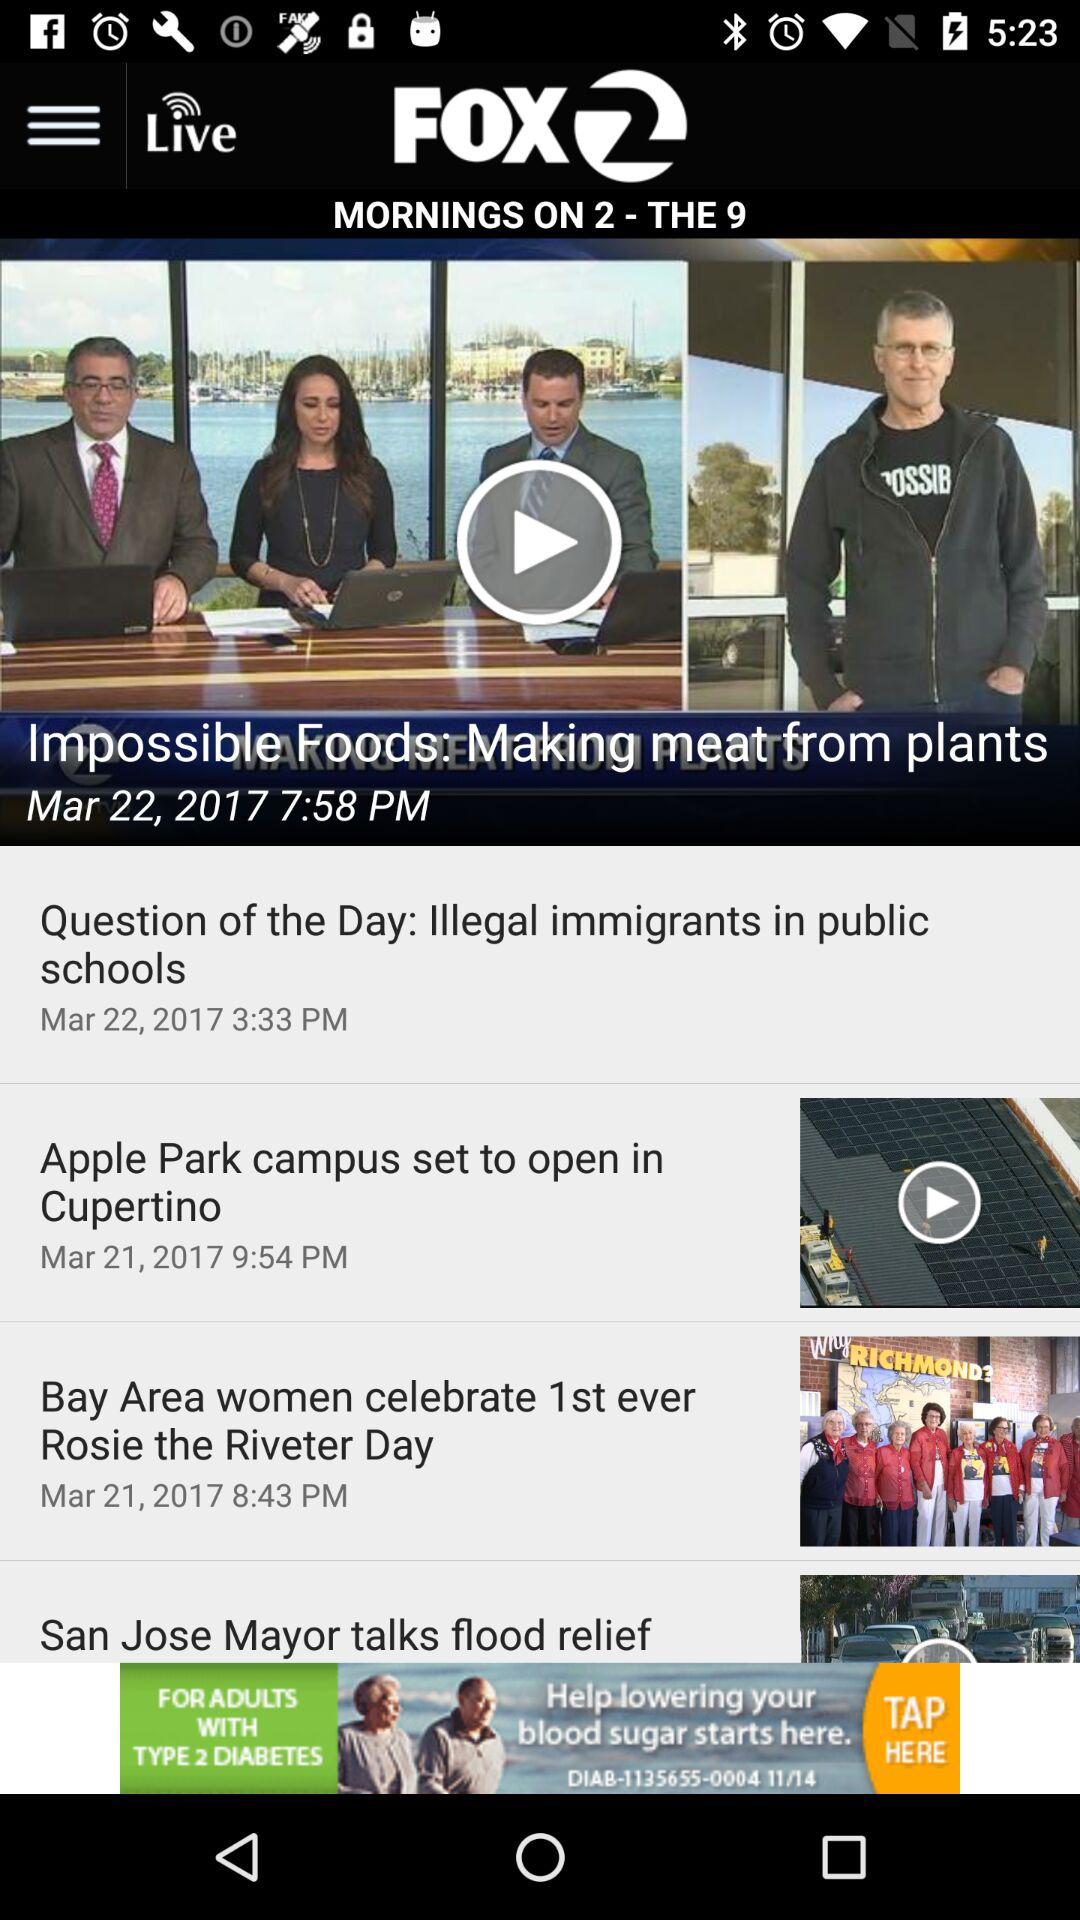What is the publication date of the article "Impossible Foods: Making meat from plants"? The publication date is March 22, 2017. 